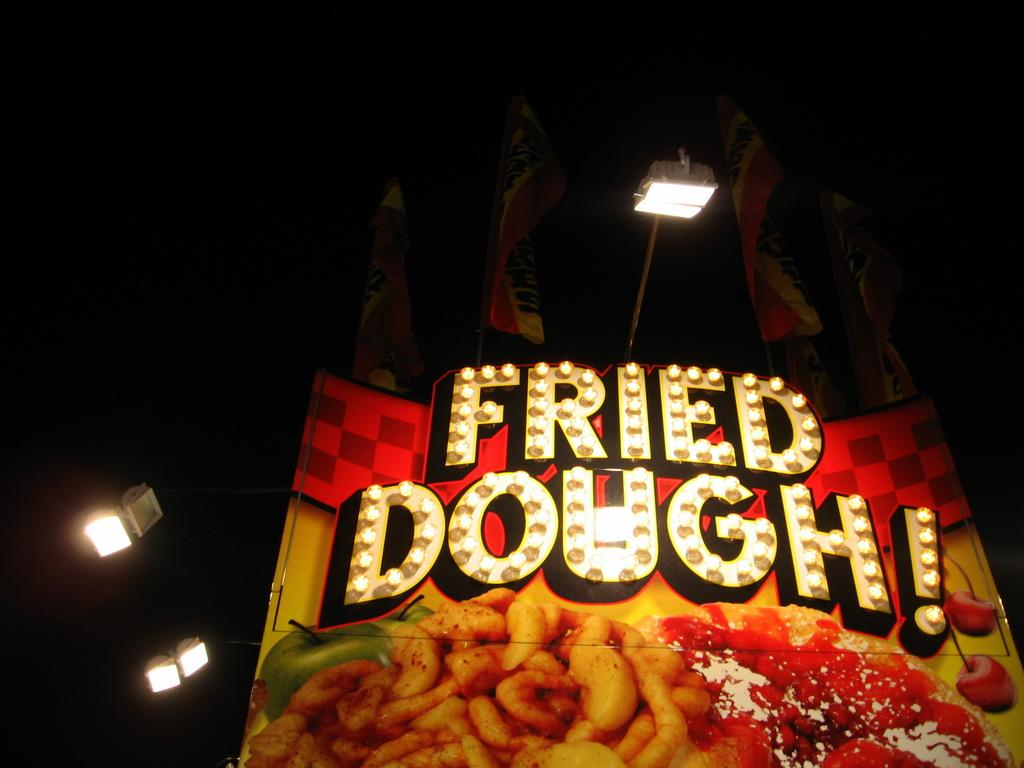What is written on the banner in the image? There is a banner with a name in the image. What can be seen in addition to the banner? There are lights and flags in the image. How many apples are hanging from the flags in the image? There are no apples present in the image; it only features a banner, lights, and flags. 